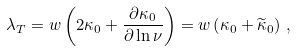<formula> <loc_0><loc_0><loc_500><loc_500>\lambda _ { T } = w \left ( 2 \kappa _ { 0 } + \frac { \partial \kappa _ { 0 } } { \partial \ln \nu } \right ) = w \left ( \kappa _ { 0 } + \widetilde { \kappa } _ { 0 } \right ) \, ,</formula> 